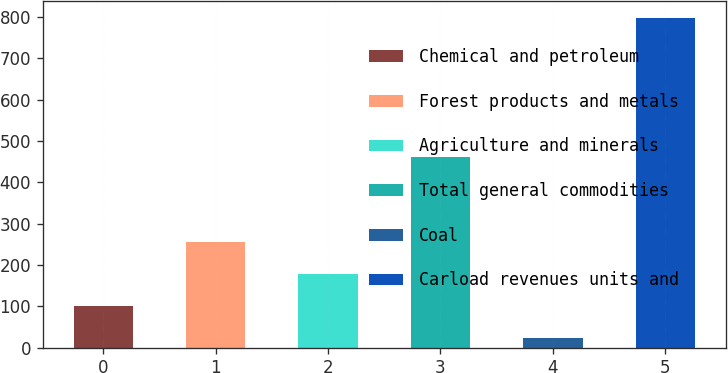<chart> <loc_0><loc_0><loc_500><loc_500><bar_chart><fcel>Chemical and petroleum<fcel>Forest products and metals<fcel>Agriculture and minerals<fcel>Total general commodities<fcel>Coal<fcel>Carload revenues units and<nl><fcel>102.16<fcel>256.68<fcel>179.42<fcel>460.6<fcel>24.9<fcel>797.5<nl></chart> 